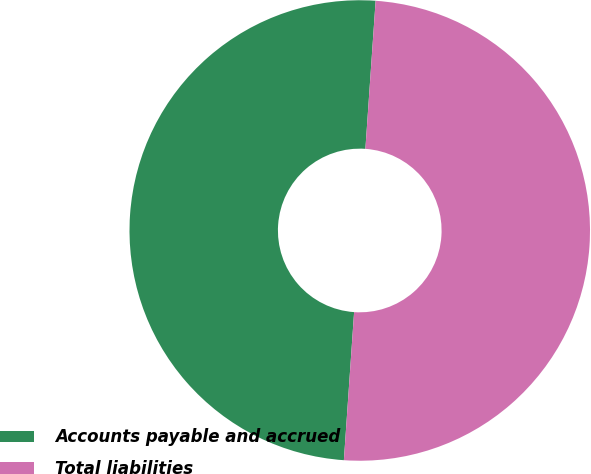Convert chart. <chart><loc_0><loc_0><loc_500><loc_500><pie_chart><fcel>Accounts payable and accrued<fcel>Total liabilities<nl><fcel>50.0%<fcel>50.0%<nl></chart> 